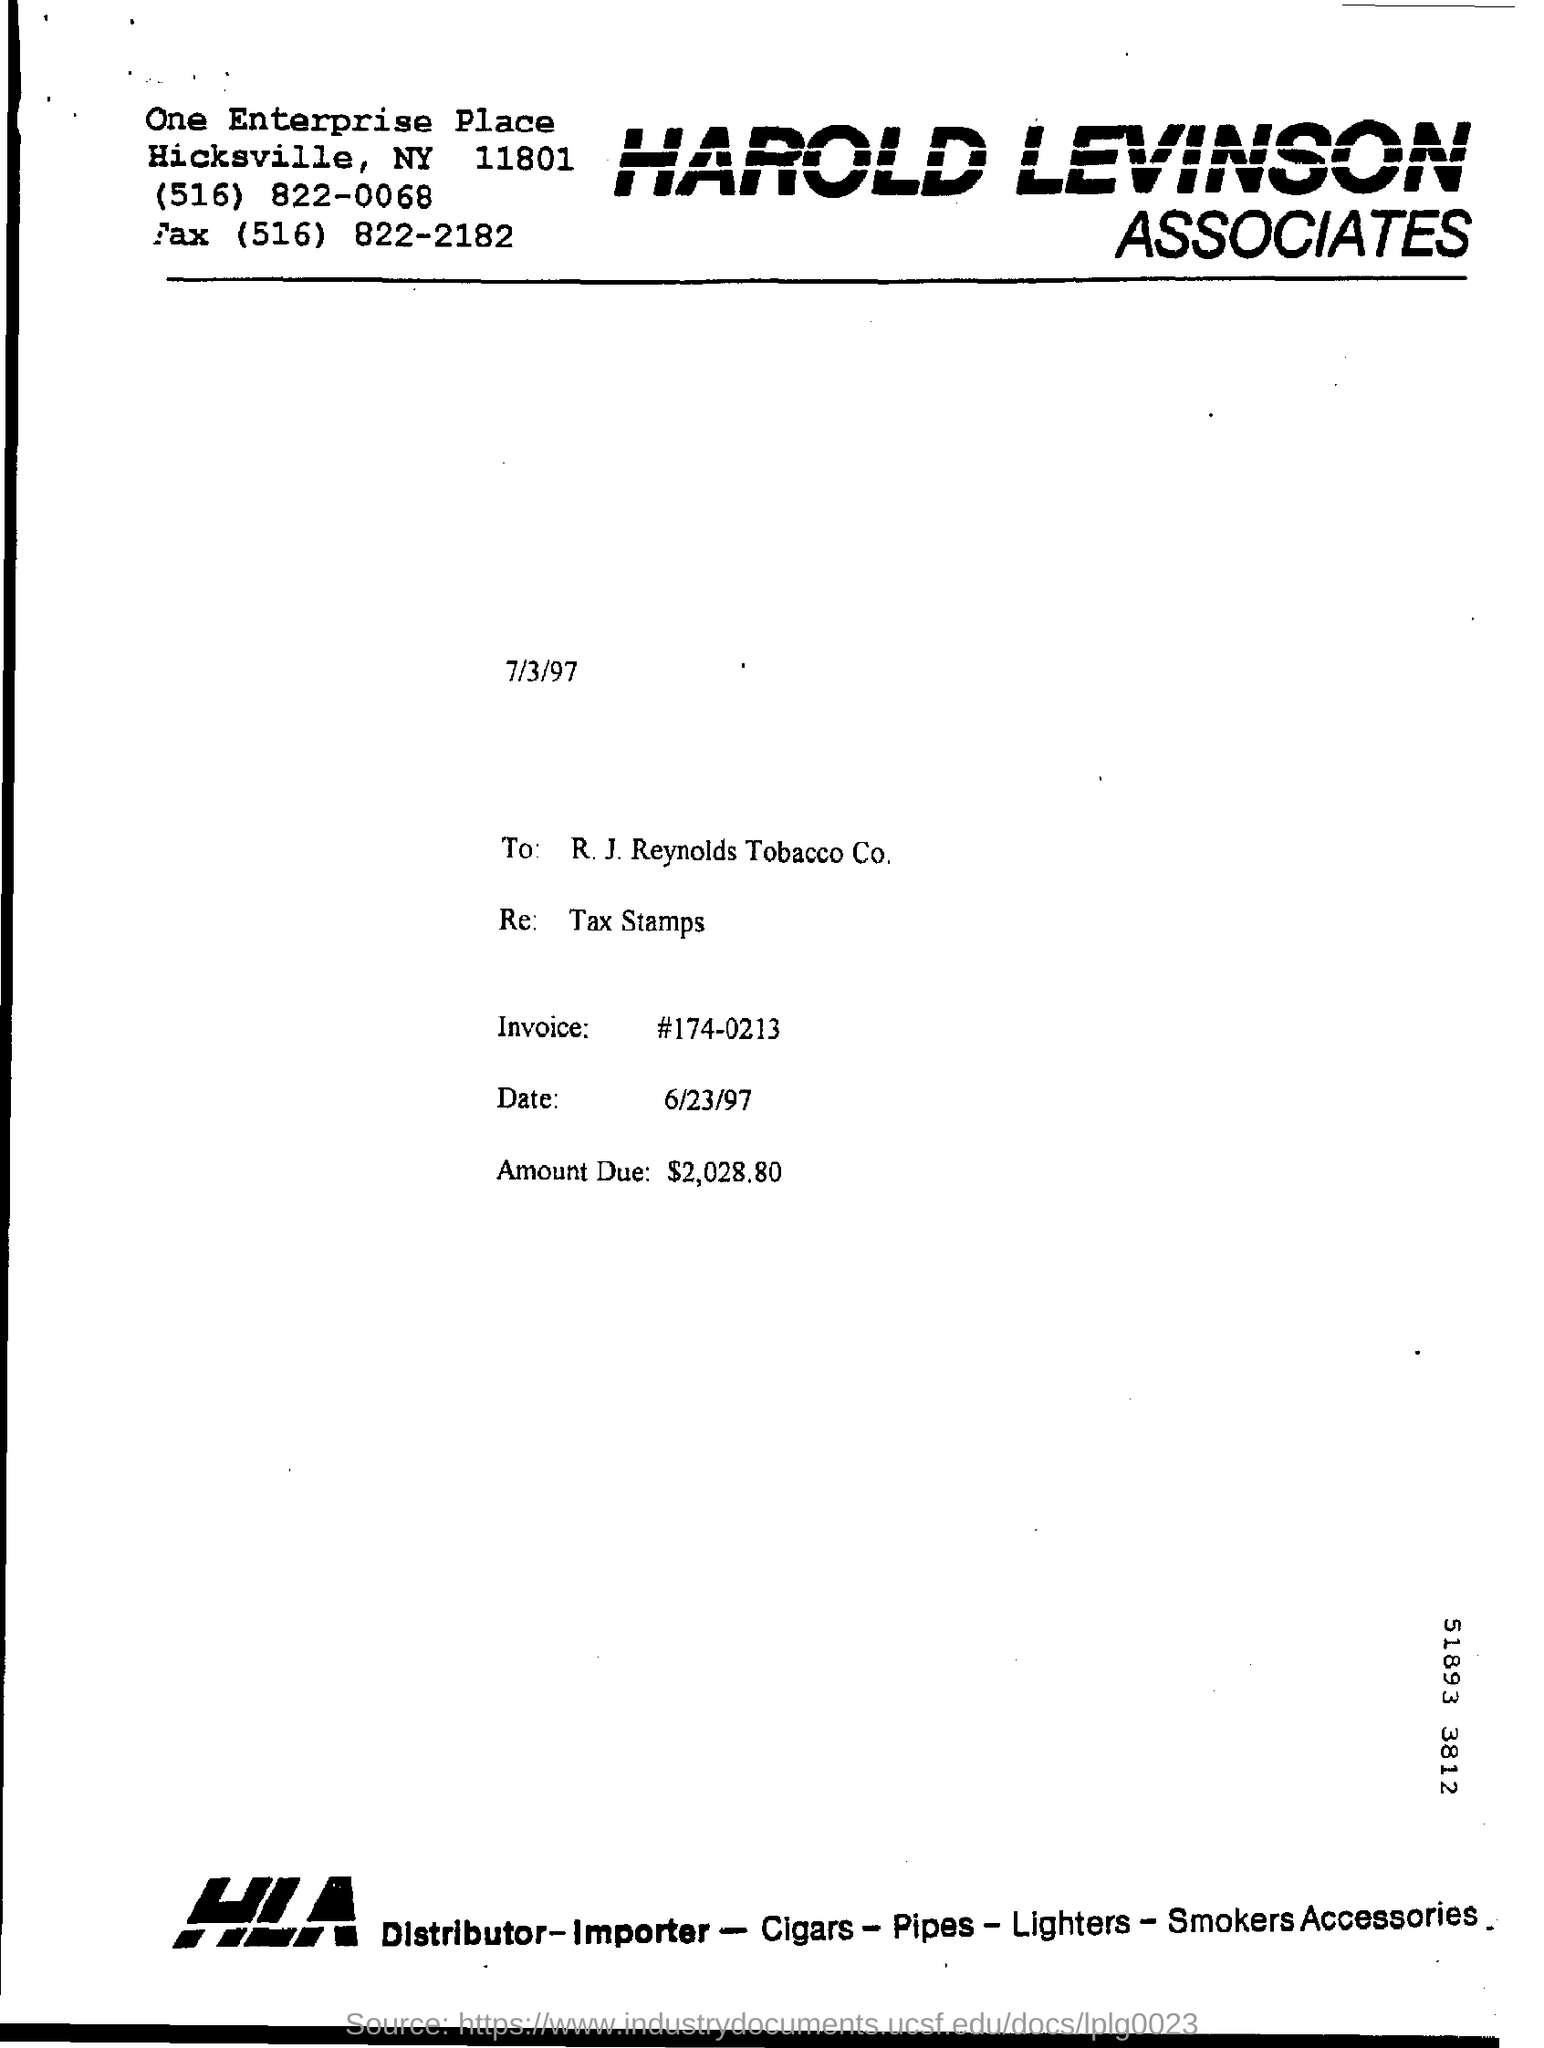Point out several critical features in this image. The amount due, as mentioned in the document, is $2,028.80. The invoice number is 174-0213. 